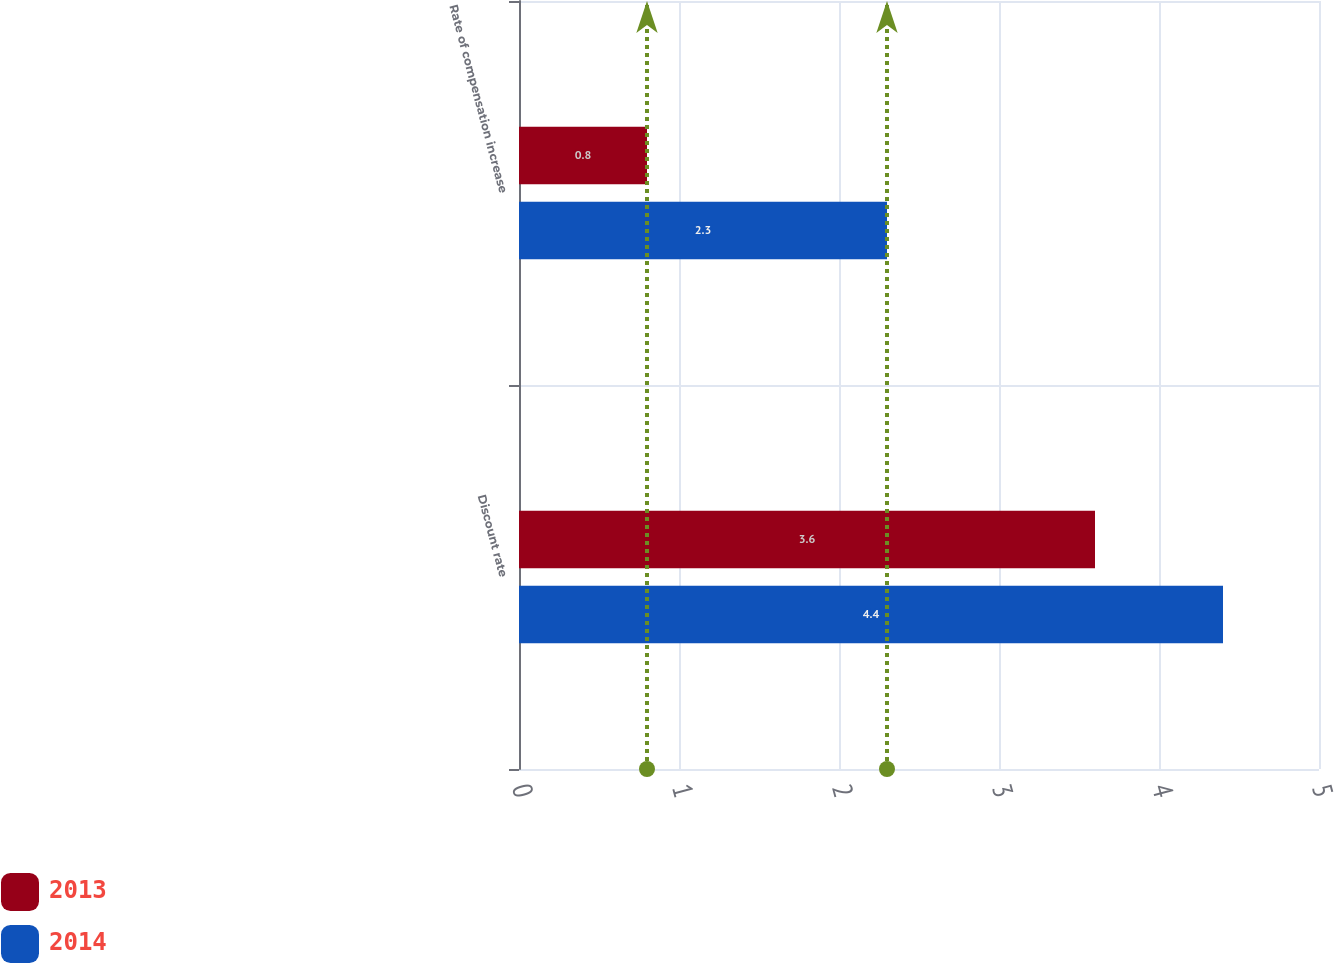<chart> <loc_0><loc_0><loc_500><loc_500><stacked_bar_chart><ecel><fcel>Discount rate<fcel>Rate of compensation increase<nl><fcel>2013<fcel>3.6<fcel>0.8<nl><fcel>2014<fcel>4.4<fcel>2.3<nl></chart> 